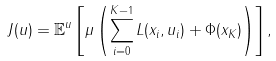<formula> <loc_0><loc_0><loc_500><loc_500>J ( u ) = \mathbb { E } ^ { u } \left [ \mu \left ( \sum _ { i = 0 } ^ { K - 1 } L ( x _ { i } , u _ { i } ) + \Phi ( x _ { K } ) \right ) \right ] ,</formula> 